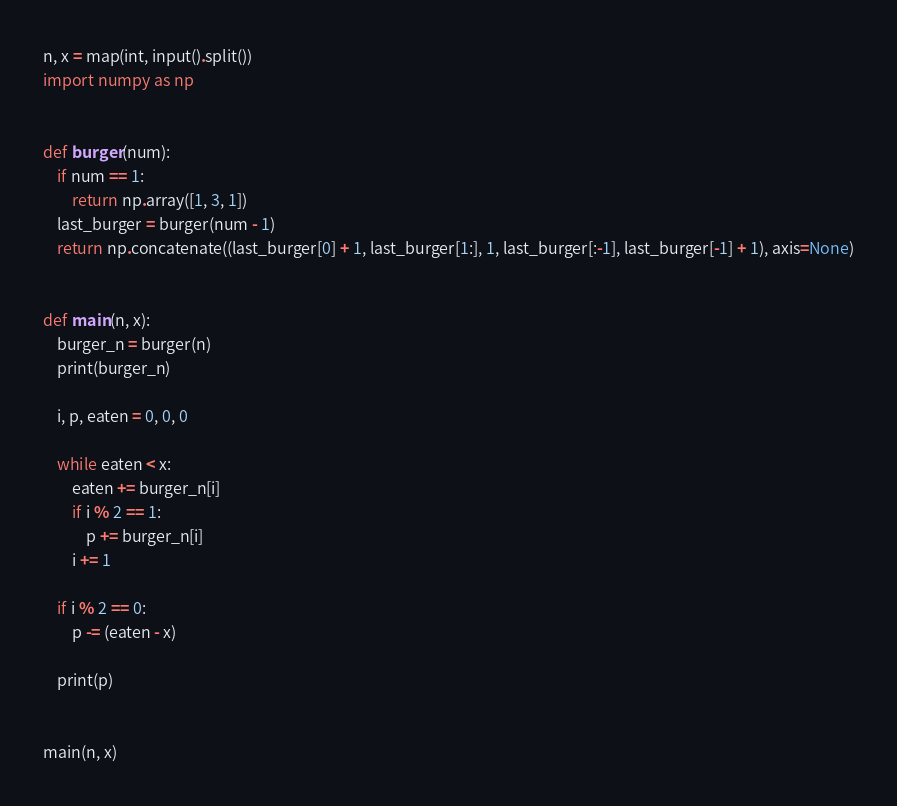<code> <loc_0><loc_0><loc_500><loc_500><_Python_>n, x = map(int, input().split())
import numpy as np


def burger(num):
    if num == 1:
        return np.array([1, 3, 1])
    last_burger = burger(num - 1)
    return np.concatenate((last_burger[0] + 1, last_burger[1:], 1, last_burger[:-1], last_burger[-1] + 1), axis=None)


def main(n, x):
    burger_n = burger(n)
    print(burger_n)

    i, p, eaten = 0, 0, 0

    while eaten < x:
        eaten += burger_n[i]
        if i % 2 == 1:
            p += burger_n[i]
        i += 1

    if i % 2 == 0:
        p -= (eaten - x)

    print(p)


main(n, x)</code> 